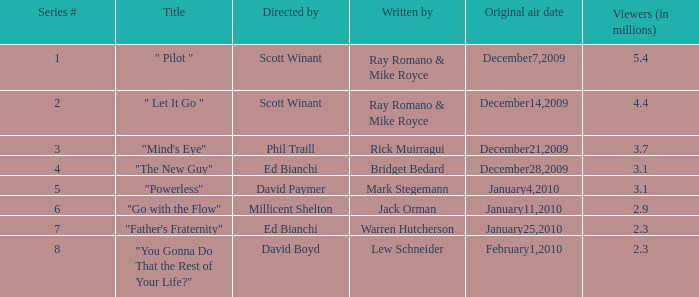What is the title of the episode written by Jack Orman? "Go with the Flow". 